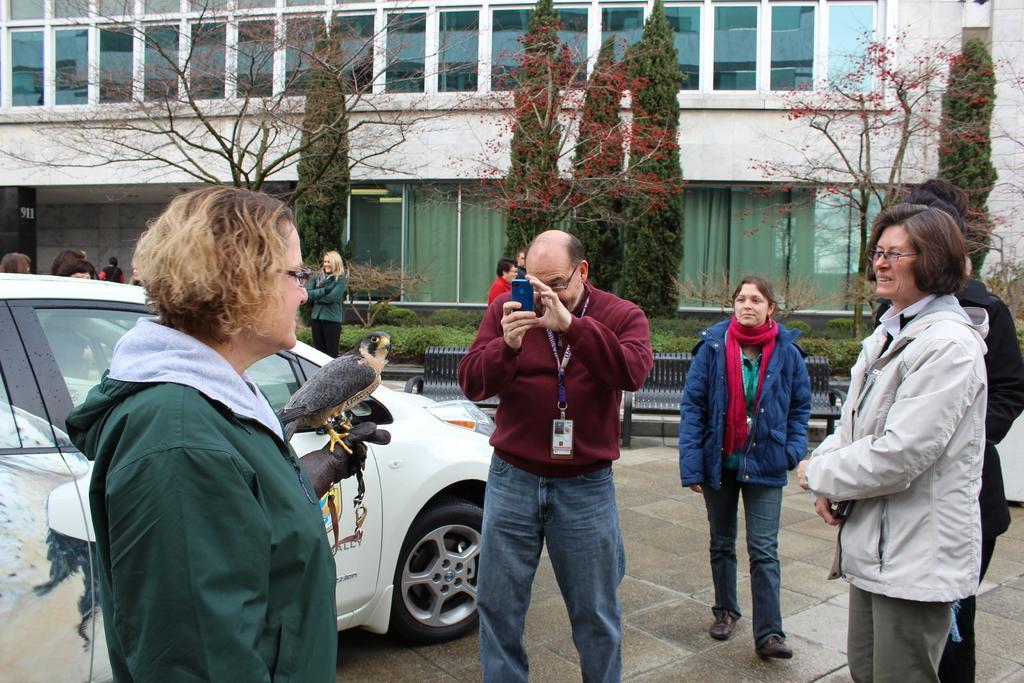In one or two sentences, can you explain what this image depicts? In this image there is a person holding the bird. In front of her there is a person taking a picture on his mobile. Behind him there are a few other people. There is a car. There are benches. There are plants. In the background of the image there are trees, buildings. There are windows and curtains. 